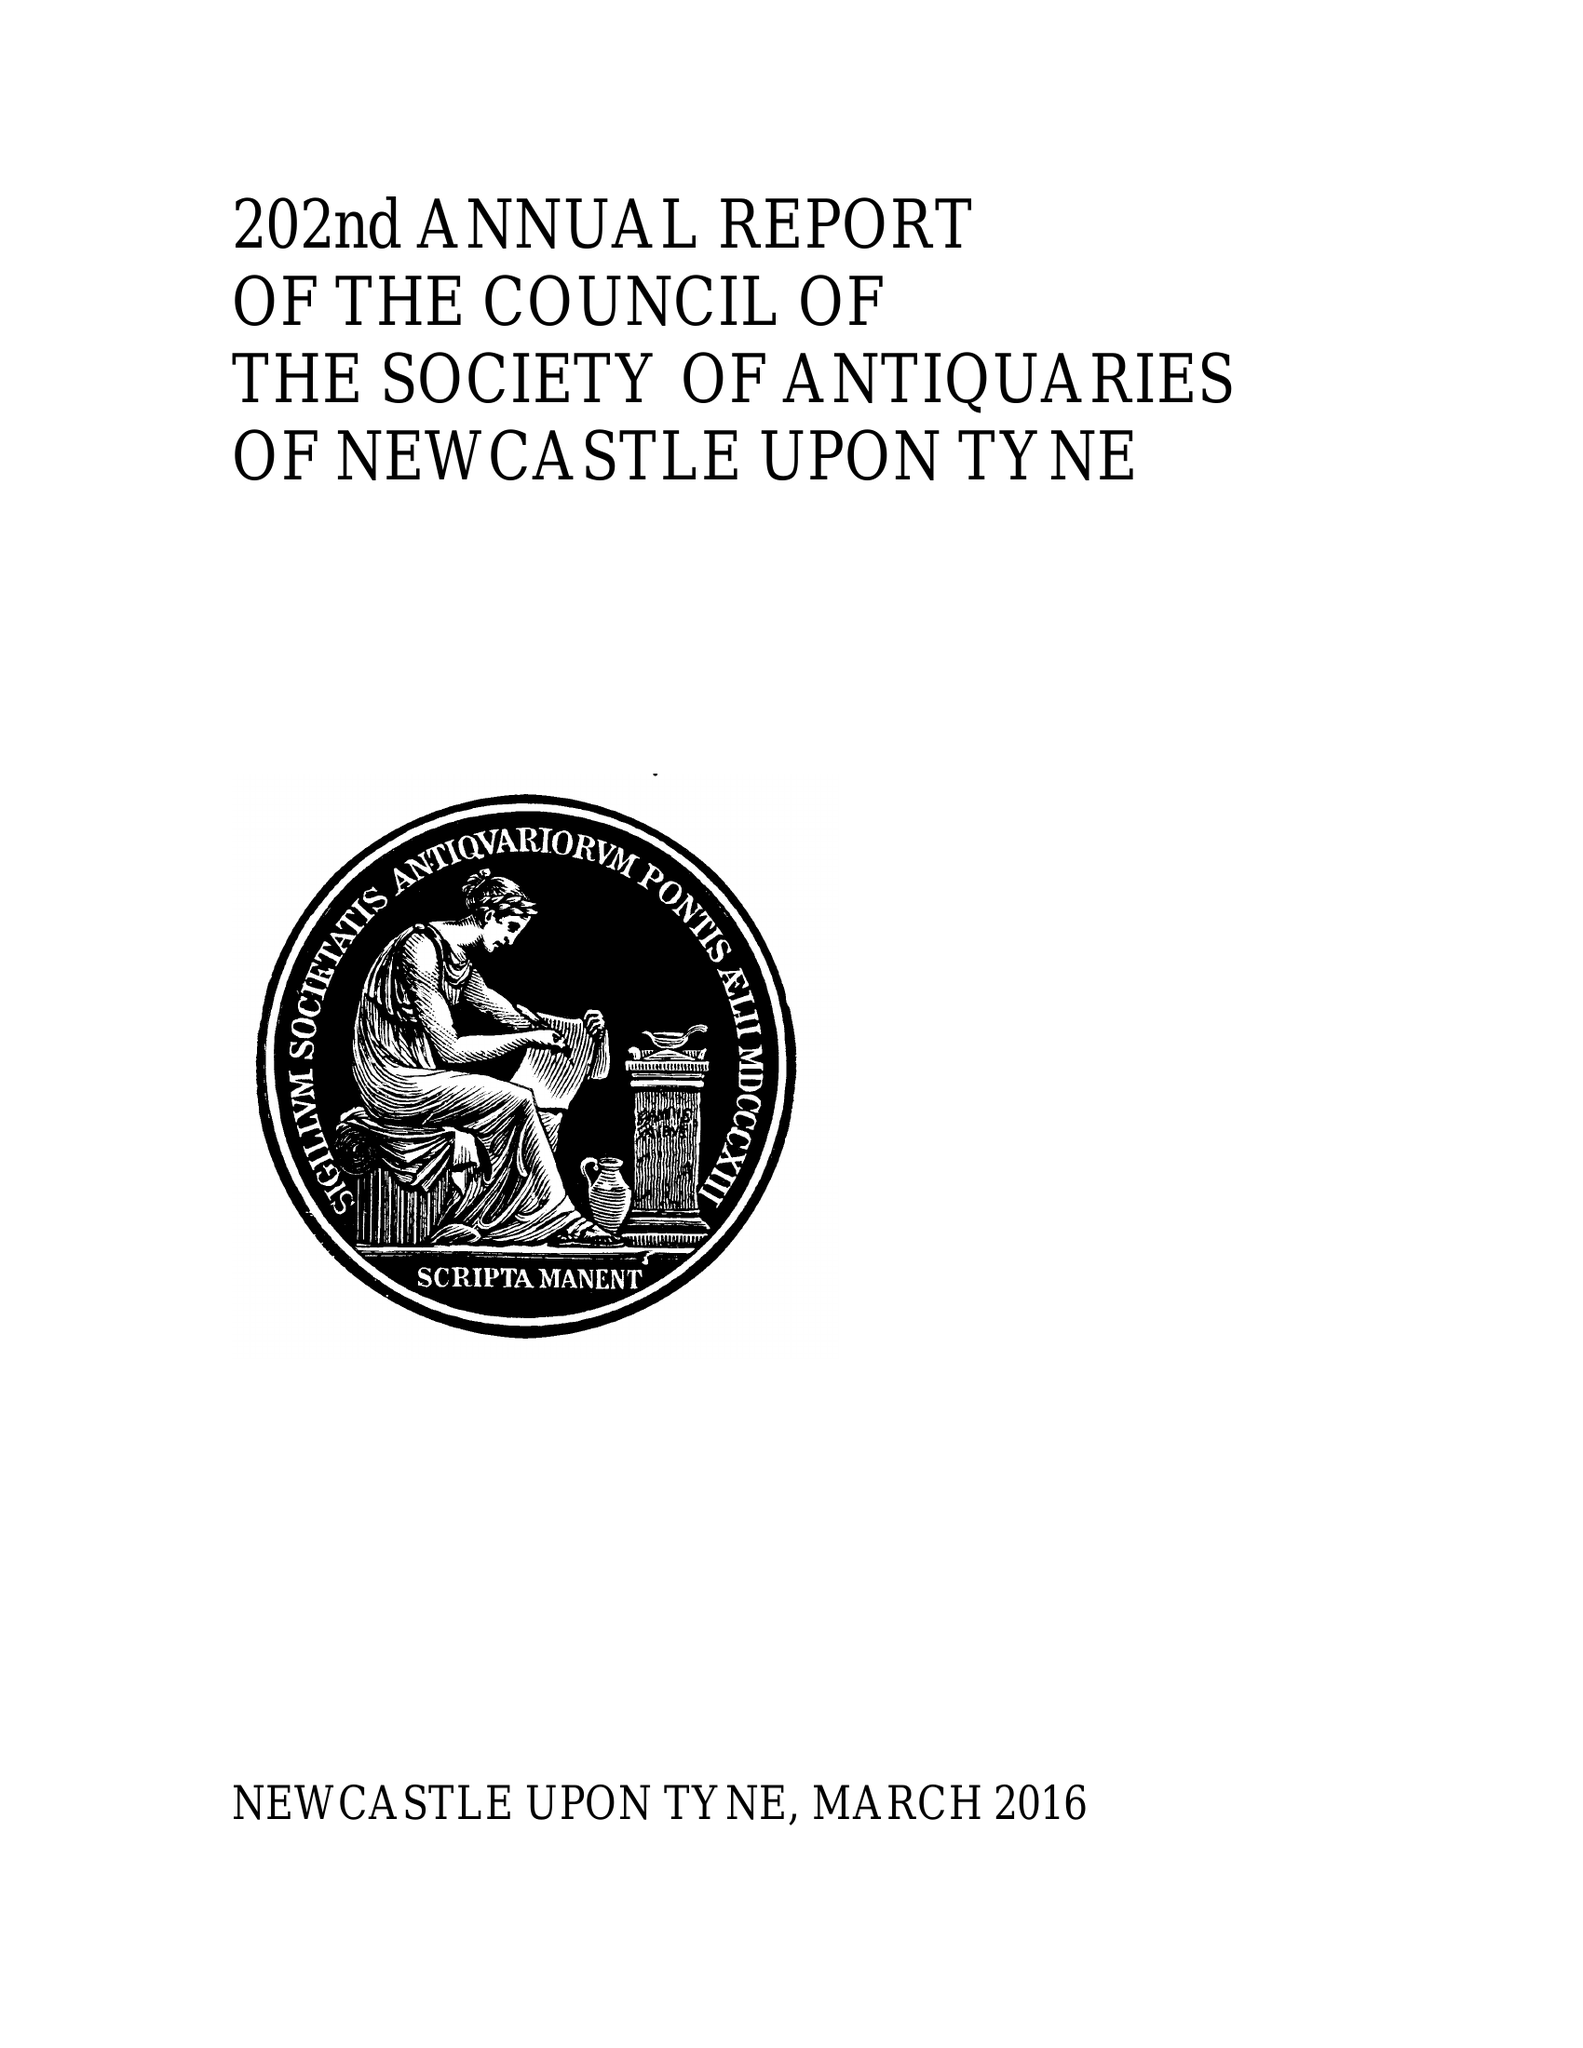What is the value for the income_annually_in_british_pounds?
Answer the question using a single word or phrase. 67147.00 